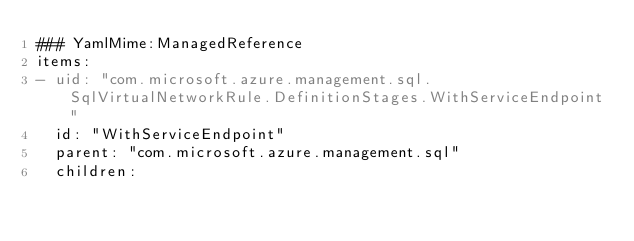<code> <loc_0><loc_0><loc_500><loc_500><_YAML_>### YamlMime:ManagedReference
items:
- uid: "com.microsoft.azure.management.sql.SqlVirtualNetworkRule.DefinitionStages.WithServiceEndpoint"
  id: "WithServiceEndpoint"
  parent: "com.microsoft.azure.management.sql"
  children:</code> 